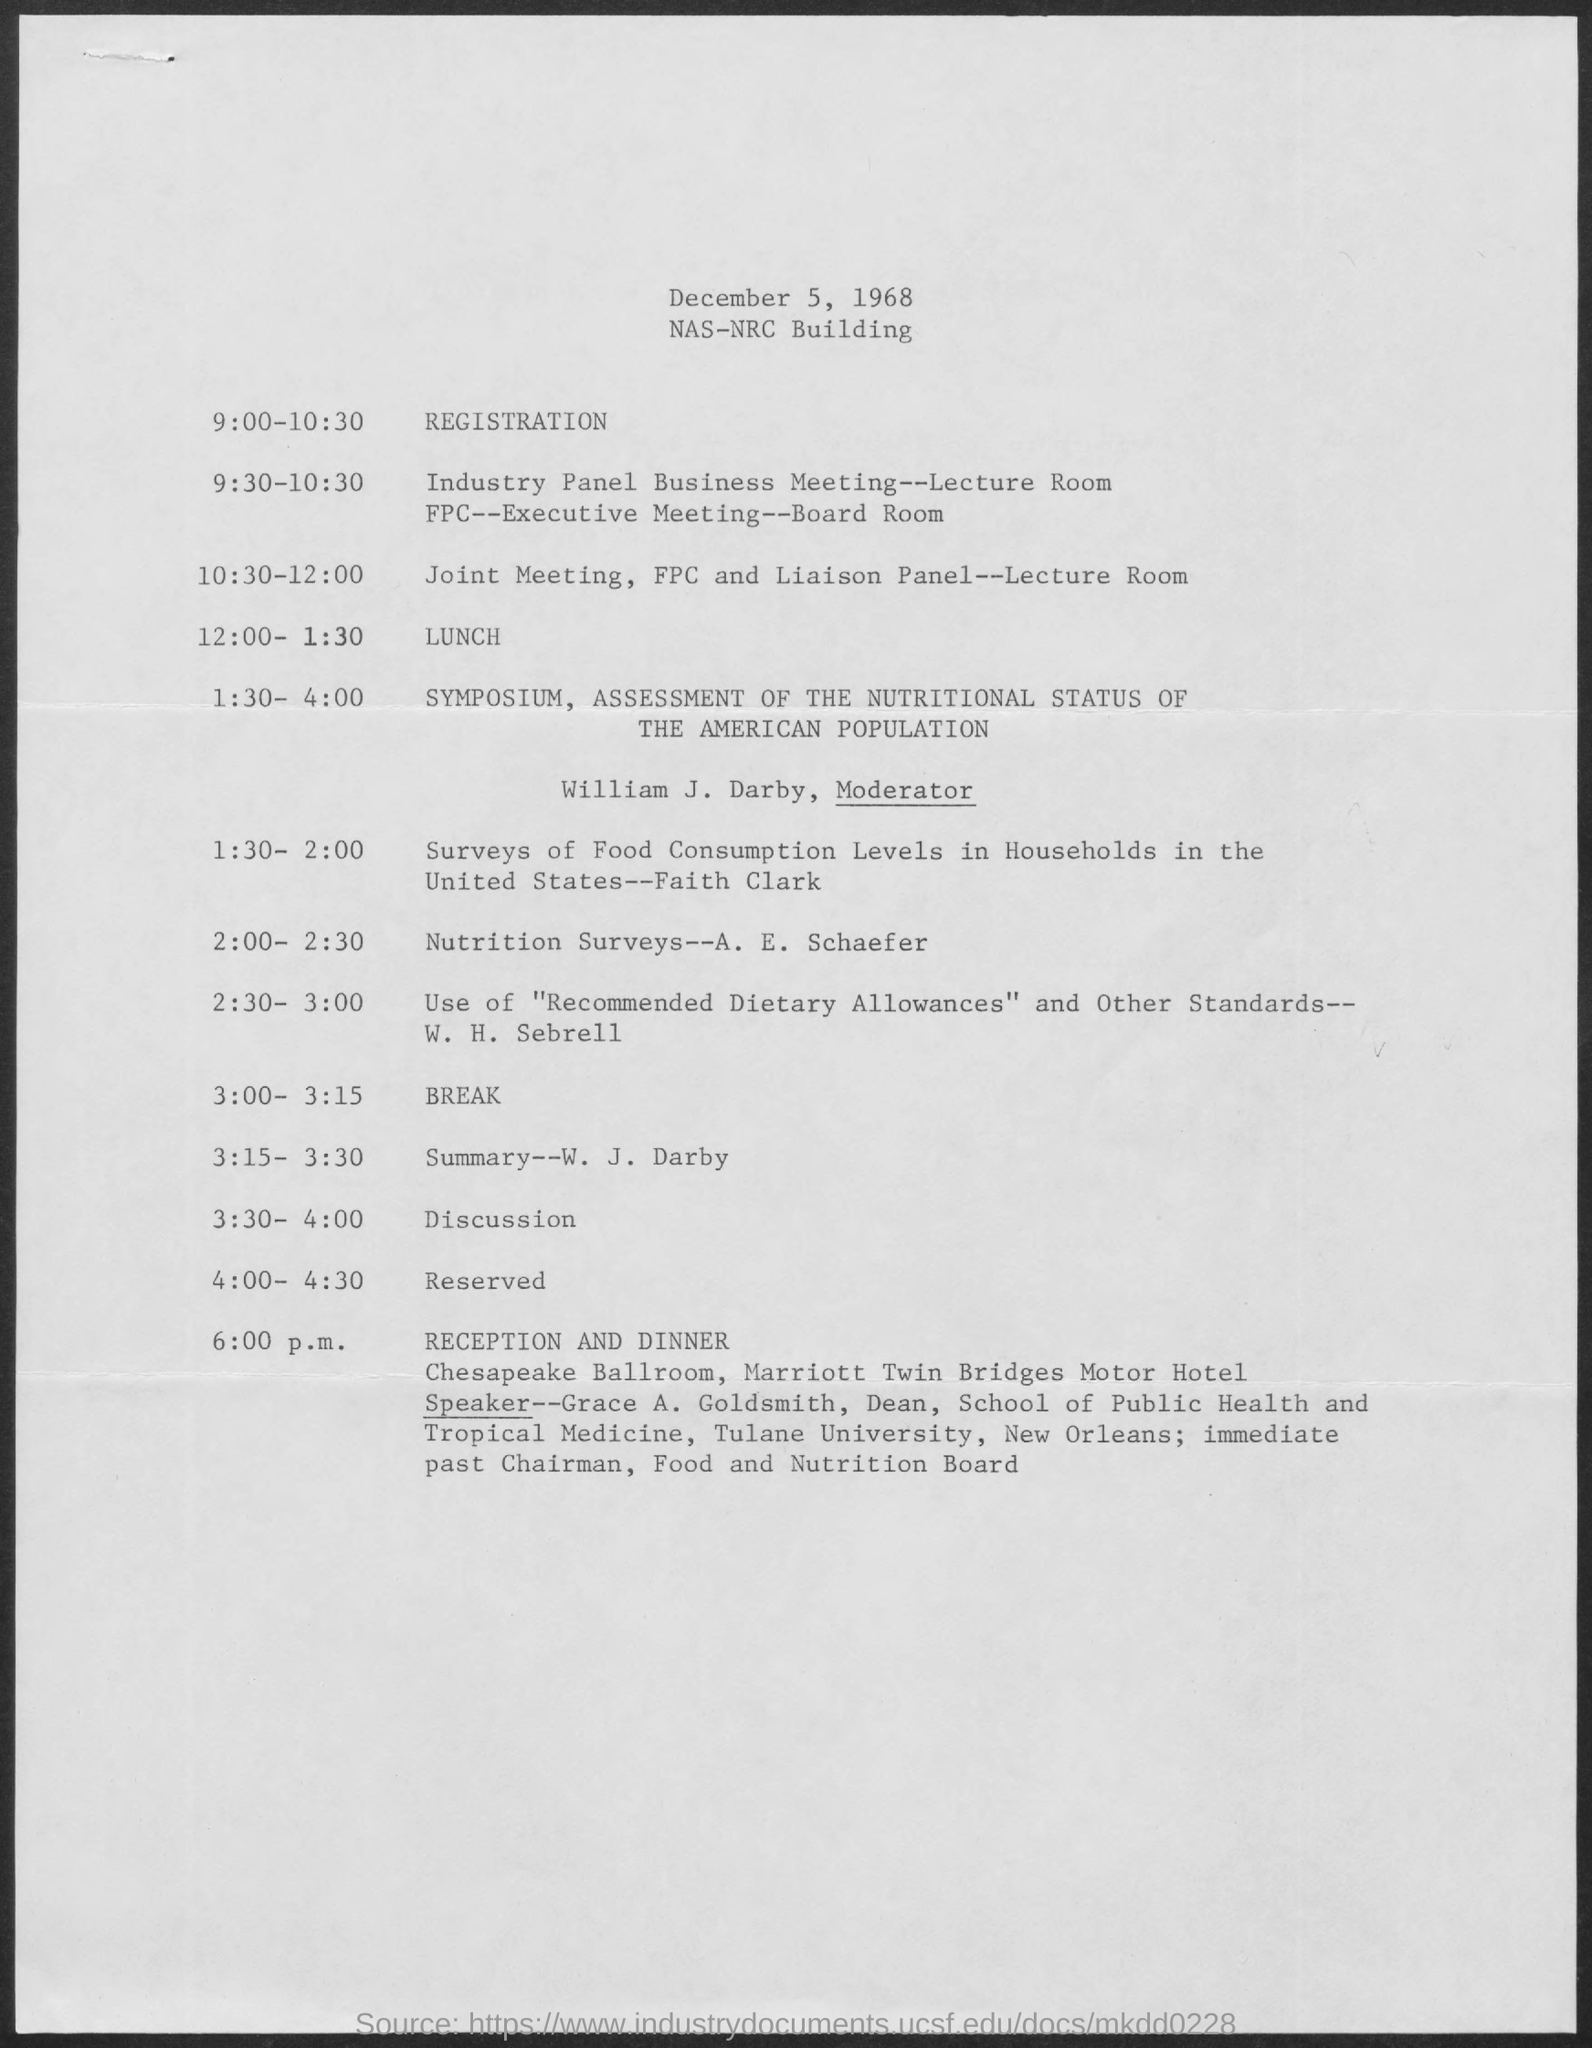What is the date on the document?
Provide a succinct answer. December 5, 1968. What time is the registration?
Provide a short and direct response. 9:00-10:30. What time is the Lunch?
Provide a short and direct response. 12:00-1:30. Who is the moderator for the symposium, assessment of the nutritional status of the American population?
Make the answer very short. William J. Darby. What time is the Break?
Make the answer very short. 3:00- 3:15. What time is the reception and dinner?
Your answer should be compact. 6:00 p.m. Where is the reception and dinner?
Offer a terse response. Chesapeake Ballroom, Marriott Twin Bridges Motor Hotel. Who is the Speaker for reception and dinner?
Provide a succinct answer. Grace A. Goldsmith. 